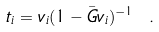Convert formula to latex. <formula><loc_0><loc_0><loc_500><loc_500>t _ { i } = v _ { i } ( 1 - \bar { G } v _ { i } ) ^ { - 1 } \ .</formula> 